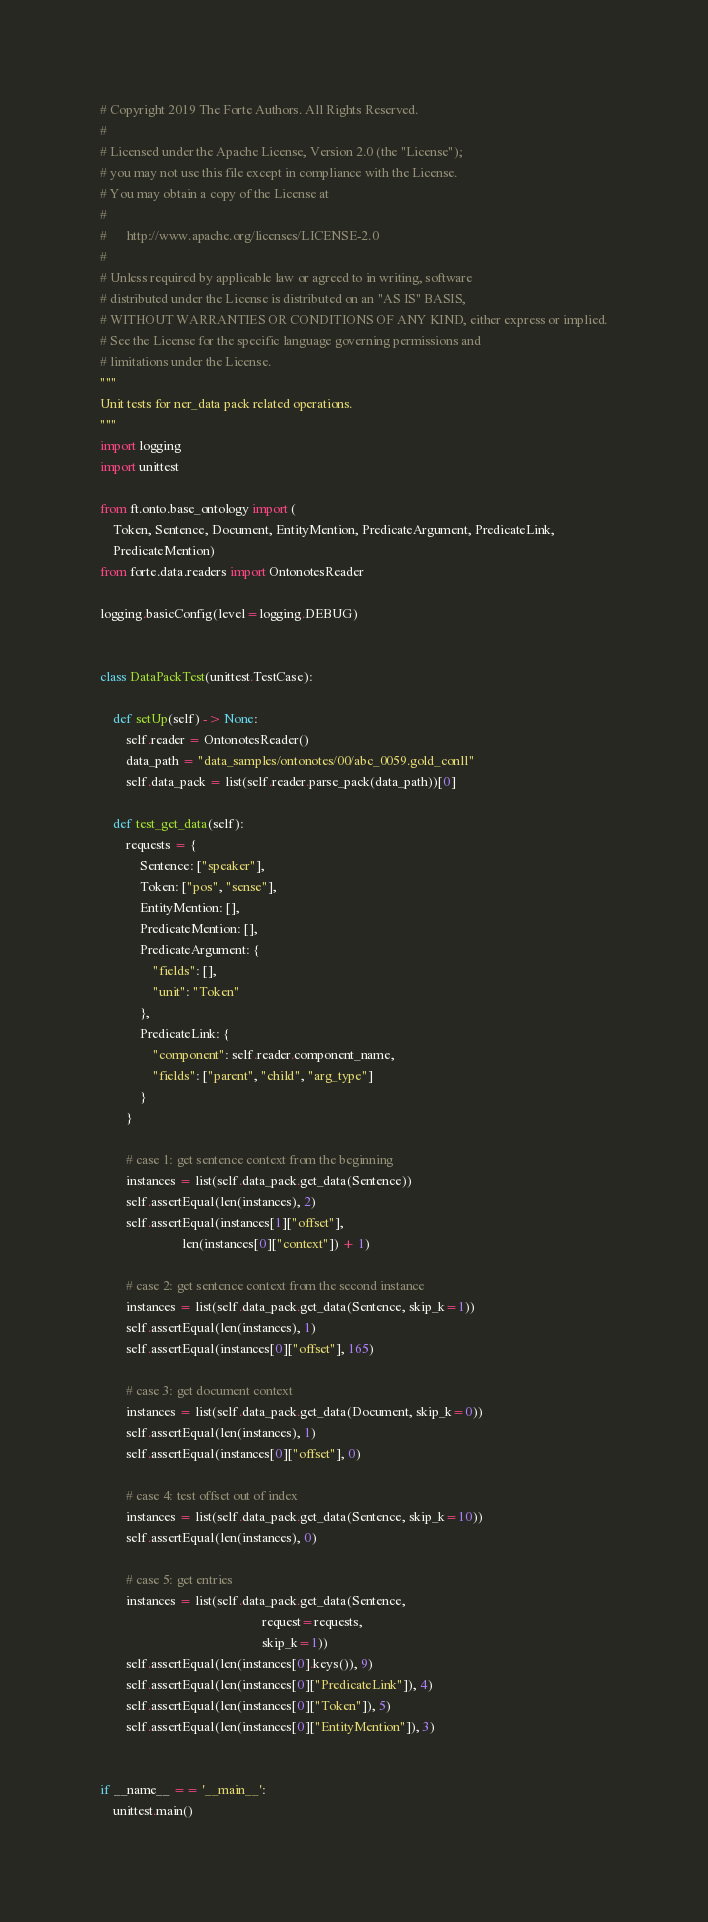<code> <loc_0><loc_0><loc_500><loc_500><_Python_># Copyright 2019 The Forte Authors. All Rights Reserved.
#
# Licensed under the Apache License, Version 2.0 (the "License");
# you may not use this file except in compliance with the License.
# You may obtain a copy of the License at
#
#      http://www.apache.org/licenses/LICENSE-2.0
#
# Unless required by applicable law or agreed to in writing, software
# distributed under the License is distributed on an "AS IS" BASIS,
# WITHOUT WARRANTIES OR CONDITIONS OF ANY KIND, either express or implied.
# See the License for the specific language governing permissions and
# limitations under the License.
"""
Unit tests for ner_data pack related operations.
"""
import logging
import unittest

from ft.onto.base_ontology import (
    Token, Sentence, Document, EntityMention, PredicateArgument, PredicateLink,
    PredicateMention)
from forte.data.readers import OntonotesReader

logging.basicConfig(level=logging.DEBUG)


class DataPackTest(unittest.TestCase):

    def setUp(self) -> None:
        self.reader = OntonotesReader()
        data_path = "data_samples/ontonotes/00/abc_0059.gold_conll"
        self.data_pack = list(self.reader.parse_pack(data_path))[0]

    def test_get_data(self):
        requests = {
            Sentence: ["speaker"],
            Token: ["pos", "sense"],
            EntityMention: [],
            PredicateMention: [],
            PredicateArgument: {
                "fields": [],
                "unit": "Token"
            },
            PredicateLink: {
                "component": self.reader.component_name,
                "fields": ["parent", "child", "arg_type"]
            }
        }

        # case 1: get sentence context from the beginning
        instances = list(self.data_pack.get_data(Sentence))
        self.assertEqual(len(instances), 2)
        self.assertEqual(instances[1]["offset"],
                         len(instances[0]["context"]) + 1)

        # case 2: get sentence context from the second instance
        instances = list(self.data_pack.get_data(Sentence, skip_k=1))
        self.assertEqual(len(instances), 1)
        self.assertEqual(instances[0]["offset"], 165)

        # case 3: get document context
        instances = list(self.data_pack.get_data(Document, skip_k=0))
        self.assertEqual(len(instances), 1)
        self.assertEqual(instances[0]["offset"], 0)

        # case 4: test offset out of index
        instances = list(self.data_pack.get_data(Sentence, skip_k=10))
        self.assertEqual(len(instances), 0)

        # case 5: get entries
        instances = list(self.data_pack.get_data(Sentence,
                                                 request=requests,
                                                 skip_k=1))
        self.assertEqual(len(instances[0].keys()), 9)
        self.assertEqual(len(instances[0]["PredicateLink"]), 4)
        self.assertEqual(len(instances[0]["Token"]), 5)
        self.assertEqual(len(instances[0]["EntityMention"]), 3)


if __name__ == '__main__':
    unittest.main()
</code> 